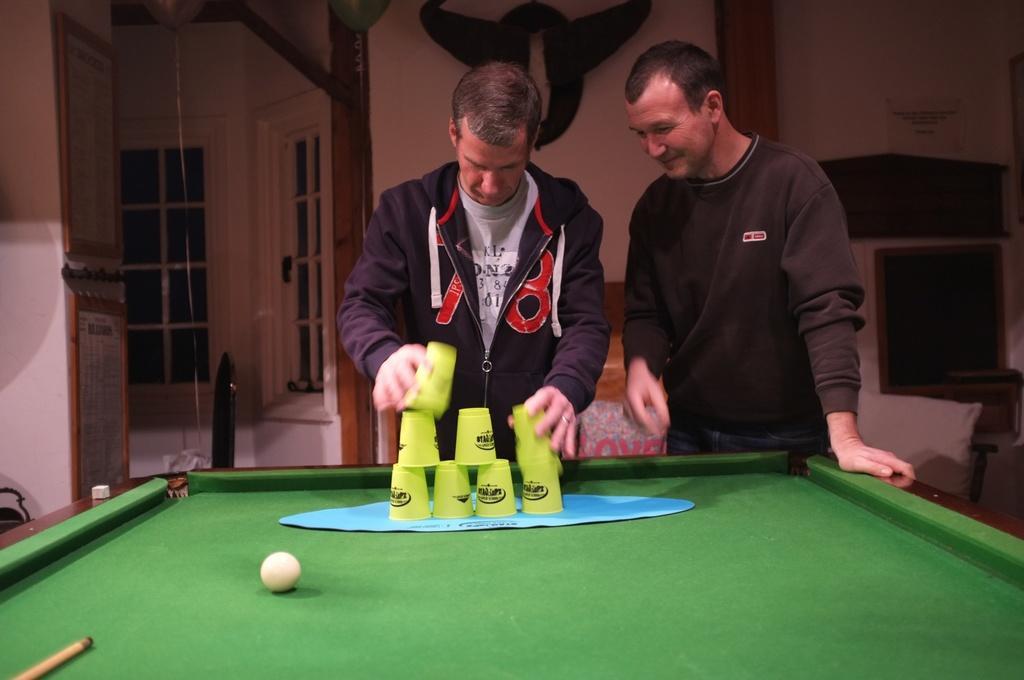Can you describe this image briefly? In this image there are two persons who are playing with glasses. At the top of the snooker table there is a ball and snooker stick and at the background of the there is a window. 